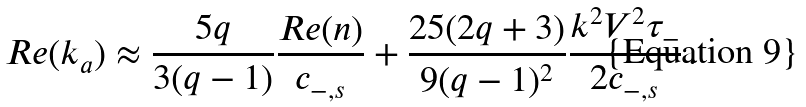<formula> <loc_0><loc_0><loc_500><loc_500>R e ( k _ { a } ) \approx \frac { 5 q } { 3 ( q - 1 ) } \frac { R e ( n ) } { c _ { - , s } } + \frac { 2 5 ( 2 q + 3 ) } { 9 ( q - 1 ) ^ { 2 } } \frac { k ^ { 2 } V ^ { 2 } \tau _ { - } } { 2 c _ { - , s } } \, .</formula> 